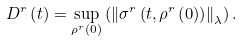<formula> <loc_0><loc_0><loc_500><loc_500>D ^ { r } \left ( t \right ) = \sup _ { \rho ^ { r } \left ( 0 \right ) } \left ( \left \| \sigma ^ { r } \left ( t , \rho ^ { r } \left ( 0 \right ) \right ) \right \| _ { \lambda } \right ) .</formula> 